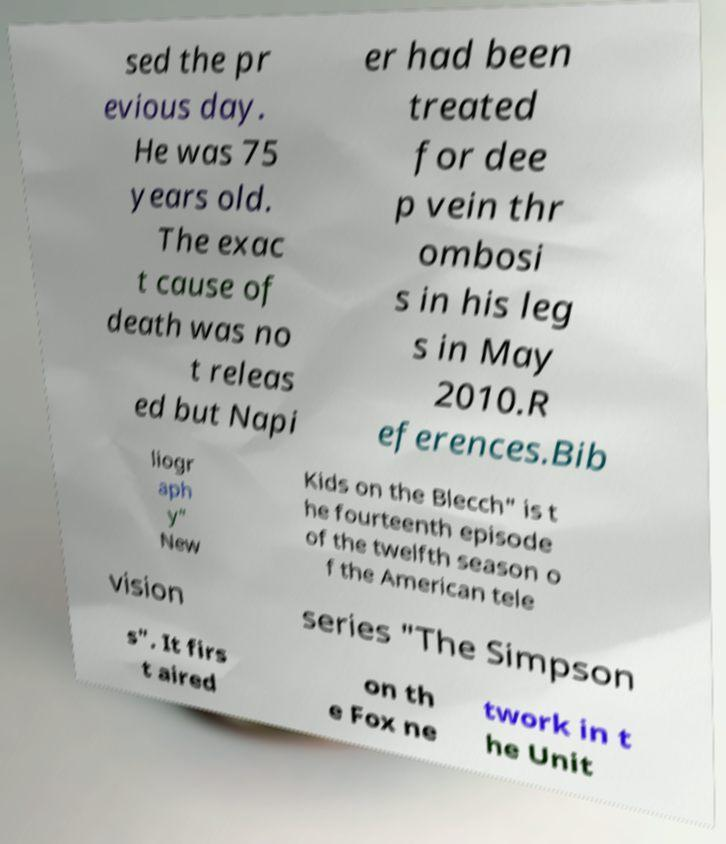Could you extract and type out the text from this image? sed the pr evious day. He was 75 years old. The exac t cause of death was no t releas ed but Napi er had been treated for dee p vein thr ombosi s in his leg s in May 2010.R eferences.Bib liogr aph y" New Kids on the Blecch" is t he fourteenth episode of the twelfth season o f the American tele vision series "The Simpson s". It firs t aired on th e Fox ne twork in t he Unit 